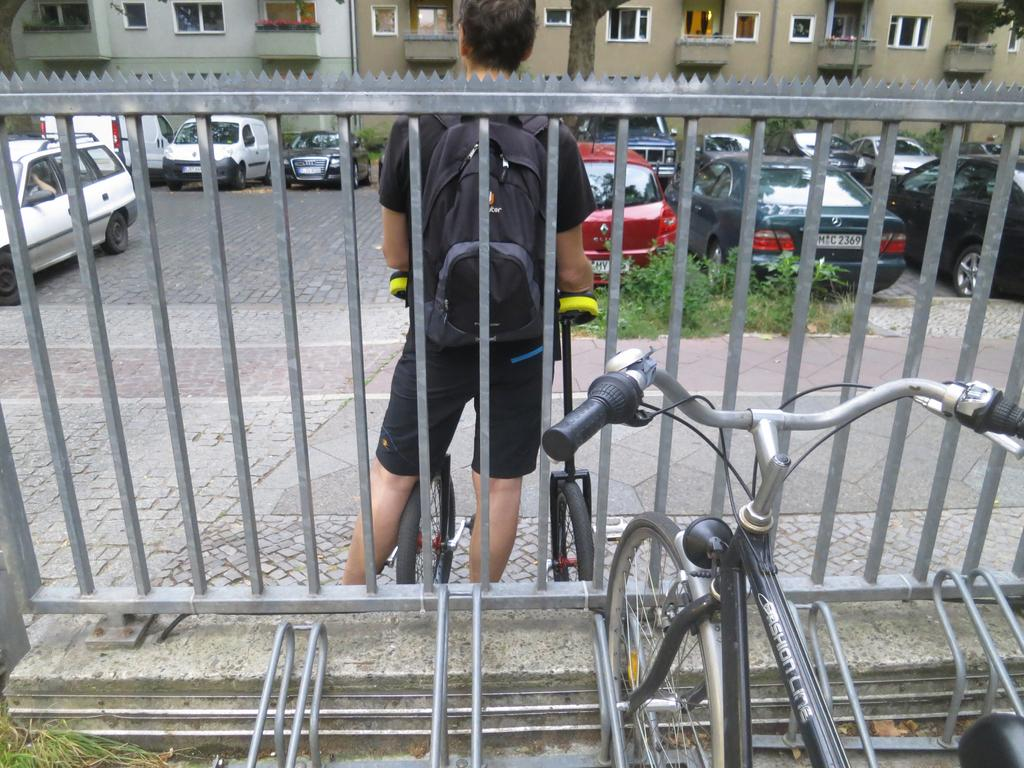What can be seen in the foreground of the image? There are bicycles, a person, and a boundary in the foreground of the image. What type of vehicles are visible in the background of the image? There are cars in the background of the image. What other elements can be seen in the background of the image? There are plants and buildings in the background of the image. What type of reward is being given to the person in the image? There is no reward being given in the image; it only shows bicycles, a person, a boundary, cars, plants, and buildings. What is the person using to attach the bicycles to the boundary in the image? There is no indication of the person attaching bicycles to the boundary or using glue in the image. 